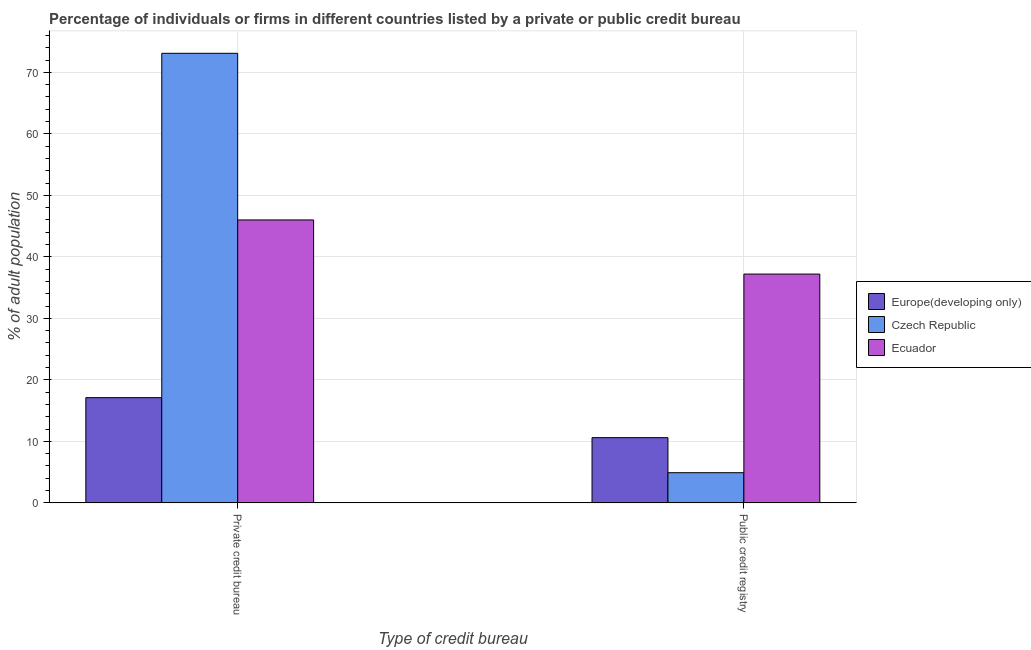How many different coloured bars are there?
Offer a terse response. 3. Are the number of bars per tick equal to the number of legend labels?
Offer a terse response. Yes. How many bars are there on the 2nd tick from the right?
Your answer should be compact. 3. What is the label of the 2nd group of bars from the left?
Provide a short and direct response. Public credit registry. What is the percentage of firms listed by public credit bureau in Ecuador?
Offer a very short reply. 37.2. Across all countries, what is the maximum percentage of firms listed by private credit bureau?
Keep it short and to the point. 73.1. Across all countries, what is the minimum percentage of firms listed by private credit bureau?
Offer a terse response. 17.11. In which country was the percentage of firms listed by public credit bureau maximum?
Your answer should be compact. Ecuador. In which country was the percentage of firms listed by private credit bureau minimum?
Give a very brief answer. Europe(developing only). What is the total percentage of firms listed by private credit bureau in the graph?
Keep it short and to the point. 136.21. What is the difference between the percentage of firms listed by public credit bureau in Czech Republic and that in Europe(developing only)?
Your answer should be very brief. -5.7. What is the difference between the percentage of firms listed by private credit bureau in Ecuador and the percentage of firms listed by public credit bureau in Europe(developing only)?
Provide a short and direct response. 35.4. What is the average percentage of firms listed by public credit bureau per country?
Your response must be concise. 17.57. What is the difference between the percentage of firms listed by public credit bureau and percentage of firms listed by private credit bureau in Europe(developing only)?
Offer a terse response. -6.51. In how many countries, is the percentage of firms listed by public credit bureau greater than 64 %?
Provide a succinct answer. 0. What is the ratio of the percentage of firms listed by private credit bureau in Czech Republic to that in Europe(developing only)?
Make the answer very short. 4.27. What does the 3rd bar from the left in Private credit bureau represents?
Ensure brevity in your answer.  Ecuador. What does the 1st bar from the right in Private credit bureau represents?
Offer a very short reply. Ecuador. Are all the bars in the graph horizontal?
Keep it short and to the point. No. Are the values on the major ticks of Y-axis written in scientific E-notation?
Offer a terse response. No. Where does the legend appear in the graph?
Provide a succinct answer. Center right. How many legend labels are there?
Make the answer very short. 3. How are the legend labels stacked?
Your answer should be compact. Vertical. What is the title of the graph?
Provide a succinct answer. Percentage of individuals or firms in different countries listed by a private or public credit bureau. Does "Brunei Darussalam" appear as one of the legend labels in the graph?
Provide a short and direct response. No. What is the label or title of the X-axis?
Your response must be concise. Type of credit bureau. What is the label or title of the Y-axis?
Keep it short and to the point. % of adult population. What is the % of adult population of Europe(developing only) in Private credit bureau?
Your answer should be very brief. 17.11. What is the % of adult population in Czech Republic in Private credit bureau?
Make the answer very short. 73.1. What is the % of adult population in Europe(developing only) in Public credit registry?
Your answer should be compact. 10.6. What is the % of adult population in Ecuador in Public credit registry?
Your answer should be compact. 37.2. Across all Type of credit bureau, what is the maximum % of adult population in Europe(developing only)?
Provide a succinct answer. 17.11. Across all Type of credit bureau, what is the maximum % of adult population of Czech Republic?
Give a very brief answer. 73.1. Across all Type of credit bureau, what is the minimum % of adult population of Czech Republic?
Keep it short and to the point. 4.9. Across all Type of credit bureau, what is the minimum % of adult population of Ecuador?
Your answer should be compact. 37.2. What is the total % of adult population of Europe(developing only) in the graph?
Offer a terse response. 27.71. What is the total % of adult population in Czech Republic in the graph?
Provide a short and direct response. 78. What is the total % of adult population of Ecuador in the graph?
Provide a short and direct response. 83.2. What is the difference between the % of adult population in Europe(developing only) in Private credit bureau and that in Public credit registry?
Offer a terse response. 6.51. What is the difference between the % of adult population of Czech Republic in Private credit bureau and that in Public credit registry?
Provide a short and direct response. 68.2. What is the difference between the % of adult population in Europe(developing only) in Private credit bureau and the % of adult population in Czech Republic in Public credit registry?
Your answer should be very brief. 12.21. What is the difference between the % of adult population in Europe(developing only) in Private credit bureau and the % of adult population in Ecuador in Public credit registry?
Provide a succinct answer. -20.09. What is the difference between the % of adult population of Czech Republic in Private credit bureau and the % of adult population of Ecuador in Public credit registry?
Offer a terse response. 35.9. What is the average % of adult population in Europe(developing only) per Type of credit bureau?
Provide a short and direct response. 13.85. What is the average % of adult population of Czech Republic per Type of credit bureau?
Keep it short and to the point. 39. What is the average % of adult population in Ecuador per Type of credit bureau?
Your response must be concise. 41.6. What is the difference between the % of adult population of Europe(developing only) and % of adult population of Czech Republic in Private credit bureau?
Your answer should be compact. -55.99. What is the difference between the % of adult population in Europe(developing only) and % of adult population in Ecuador in Private credit bureau?
Make the answer very short. -28.89. What is the difference between the % of adult population in Czech Republic and % of adult population in Ecuador in Private credit bureau?
Ensure brevity in your answer.  27.1. What is the difference between the % of adult population in Europe(developing only) and % of adult population in Czech Republic in Public credit registry?
Your answer should be compact. 5.7. What is the difference between the % of adult population in Europe(developing only) and % of adult population in Ecuador in Public credit registry?
Ensure brevity in your answer.  -26.6. What is the difference between the % of adult population of Czech Republic and % of adult population of Ecuador in Public credit registry?
Make the answer very short. -32.3. What is the ratio of the % of adult population of Europe(developing only) in Private credit bureau to that in Public credit registry?
Your answer should be compact. 1.61. What is the ratio of the % of adult population in Czech Republic in Private credit bureau to that in Public credit registry?
Provide a succinct answer. 14.92. What is the ratio of the % of adult population of Ecuador in Private credit bureau to that in Public credit registry?
Offer a terse response. 1.24. What is the difference between the highest and the second highest % of adult population in Europe(developing only)?
Offer a terse response. 6.51. What is the difference between the highest and the second highest % of adult population of Czech Republic?
Your answer should be very brief. 68.2. What is the difference between the highest and the second highest % of adult population in Ecuador?
Your response must be concise. 8.8. What is the difference between the highest and the lowest % of adult population in Europe(developing only)?
Your answer should be very brief. 6.51. What is the difference between the highest and the lowest % of adult population of Czech Republic?
Ensure brevity in your answer.  68.2. 